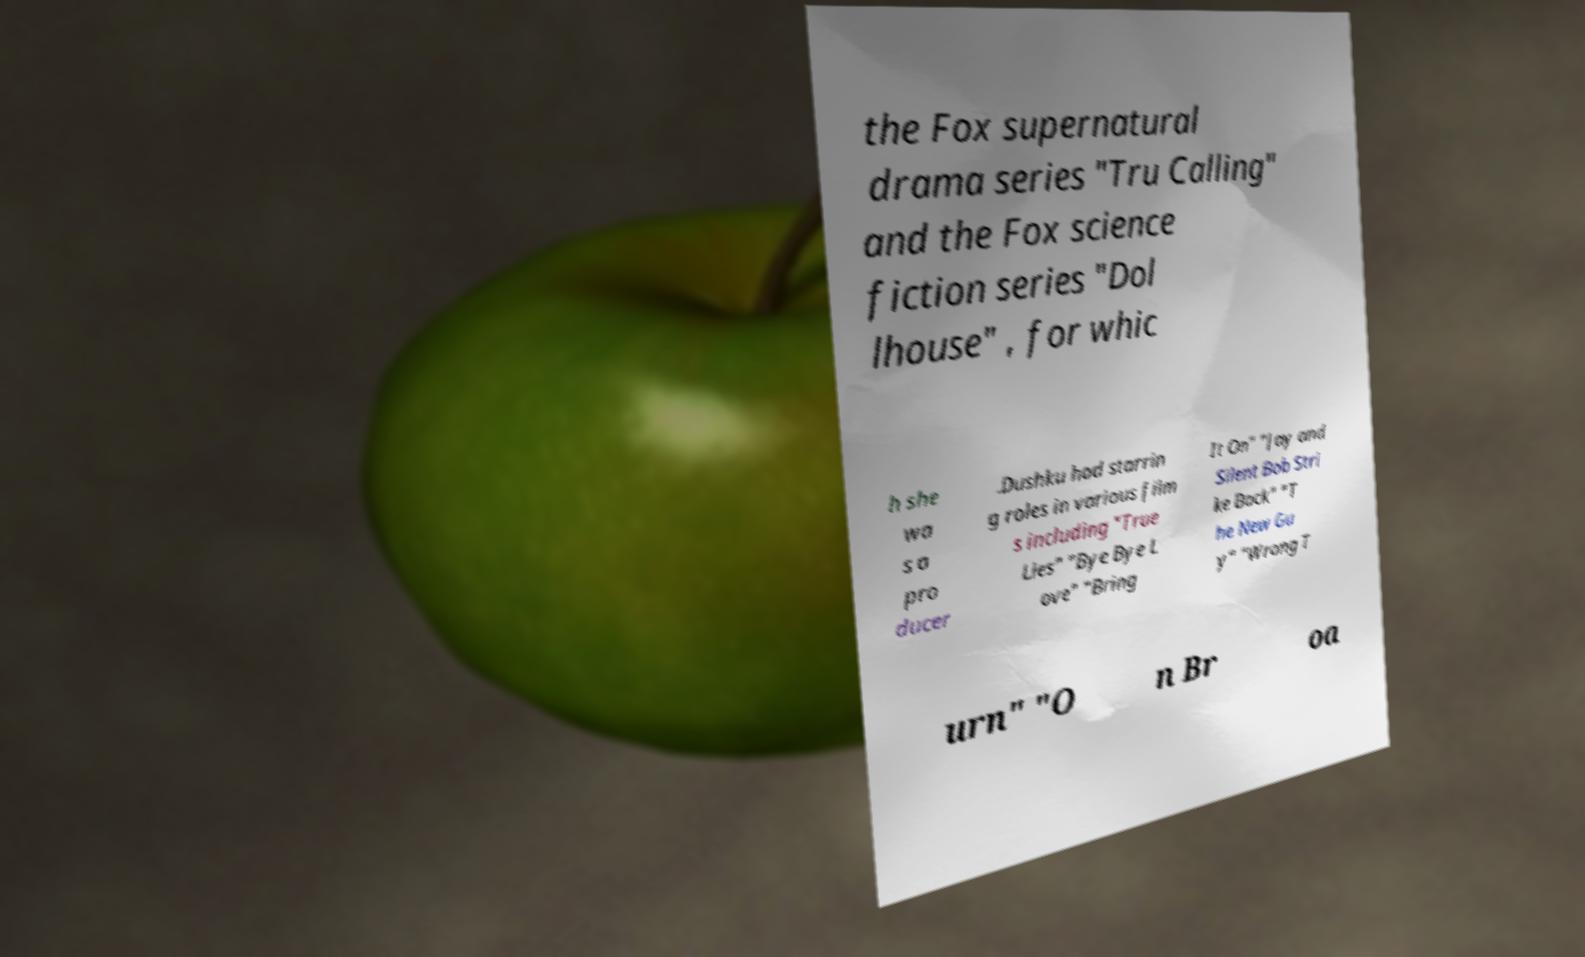Can you accurately transcribe the text from the provided image for me? the Fox supernatural drama series "Tru Calling" and the Fox science fiction series "Dol lhouse" , for whic h she wa s a pro ducer .Dushku had starrin g roles in various film s including "True Lies" "Bye Bye L ove" "Bring It On" "Jay and Silent Bob Stri ke Back" "T he New Gu y" "Wrong T urn" "O n Br oa 